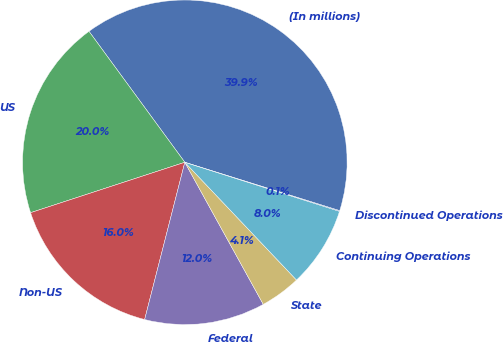Convert chart to OTSL. <chart><loc_0><loc_0><loc_500><loc_500><pie_chart><fcel>(In millions)<fcel>US<fcel>Non-US<fcel>Federal<fcel>State<fcel>Continuing Operations<fcel>Discontinued Operations<nl><fcel>39.87%<fcel>19.97%<fcel>15.99%<fcel>12.01%<fcel>4.05%<fcel>8.03%<fcel>0.07%<nl></chart> 